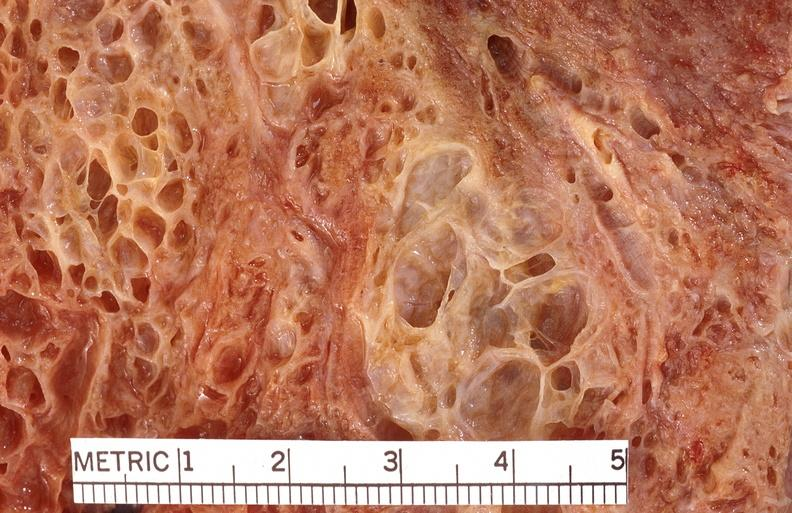what is present?
Answer the question using a single word or phrase. Respiratory 